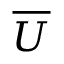Convert formula to latex. <formula><loc_0><loc_0><loc_500><loc_500>\overline { U }</formula> 